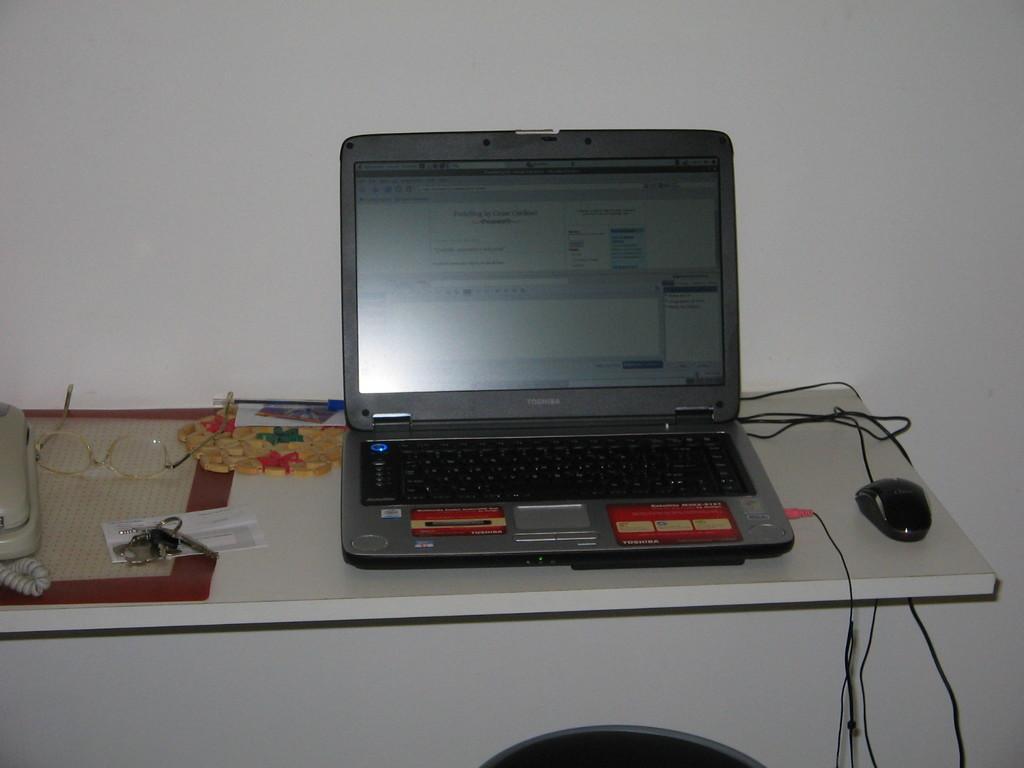Can you describe this image briefly? In this image, there is a shelf. On the shelf, we can see a laptop, mouse, glasses, papers, mat, telephone and few objects. We can see a few wires on the shelf. In the background, there is a wall. We can see a black color object at the bottom of the image.  